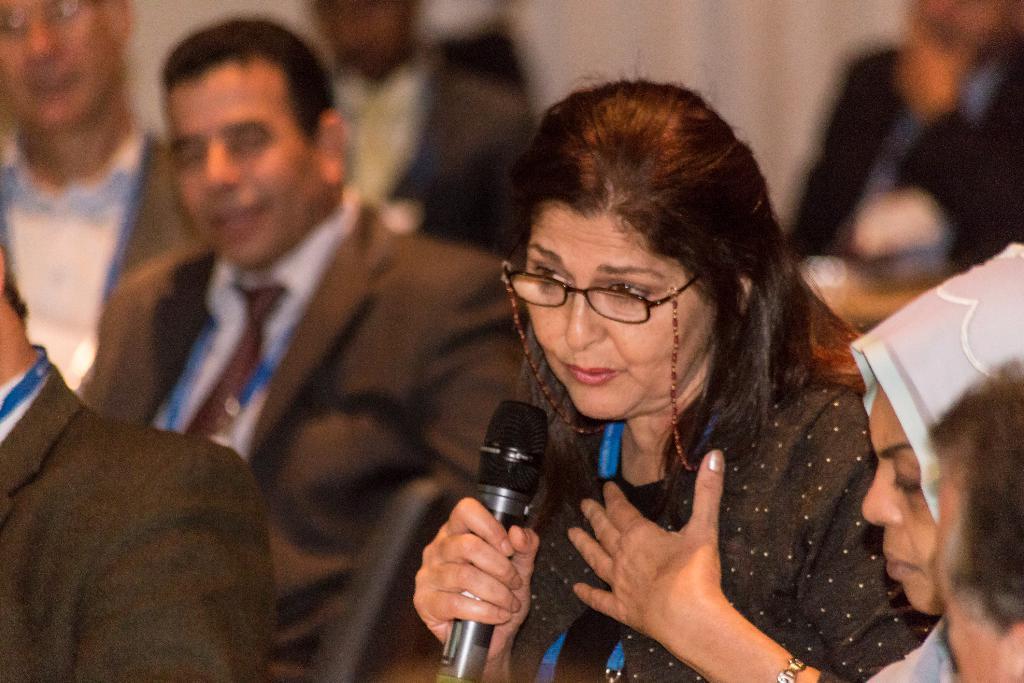Please provide a concise description of this image. In this image there are group of people. There is a woman holding a mic. 